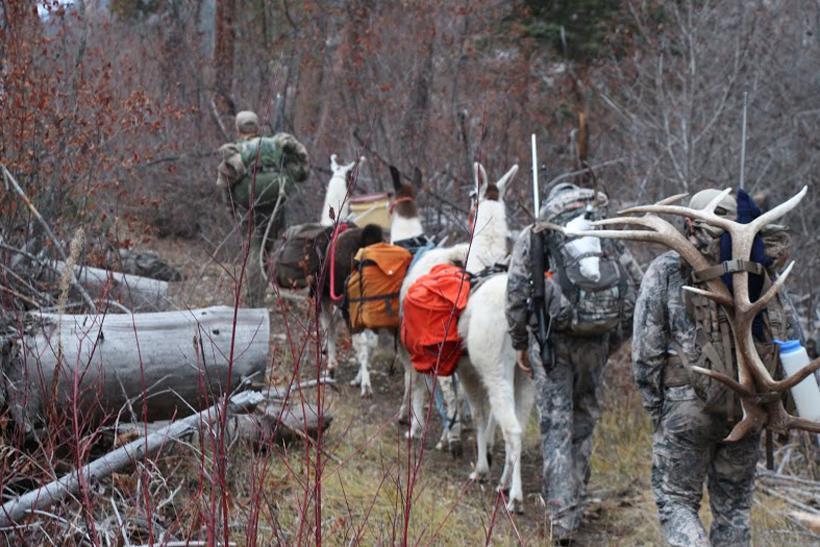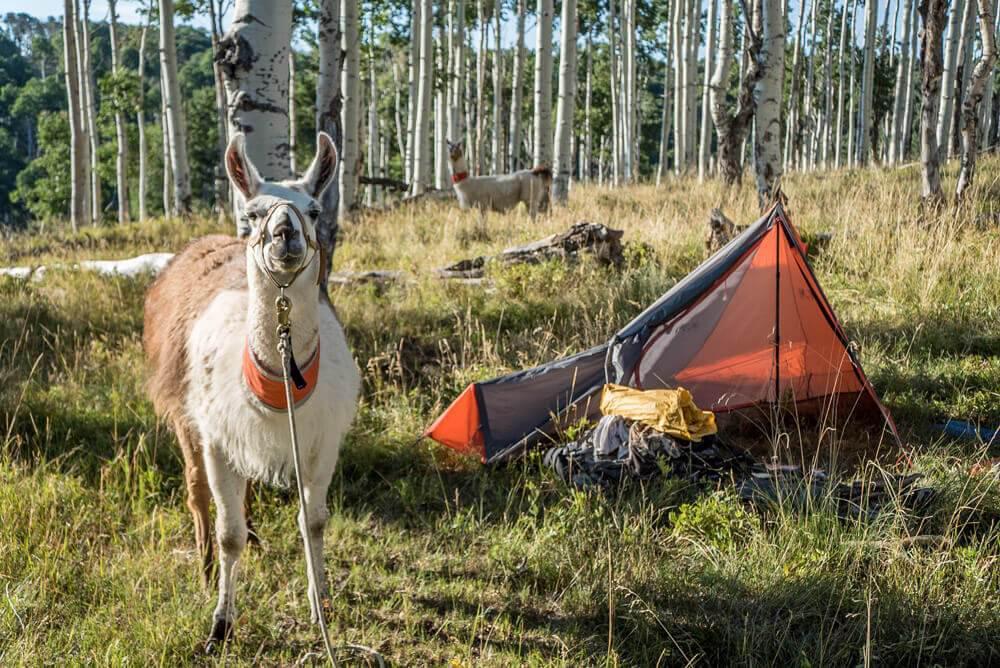The first image is the image on the left, the second image is the image on the right. Evaluate the accuracy of this statement regarding the images: "There are two alpaca in one image and multiple alpacas in the other image.". Is it true? Answer yes or no. Yes. The first image is the image on the left, the second image is the image on the right. Examine the images to the left and right. Is the description "One man in camo with a bow is leading no more than two packed llamas leftward in one image." accurate? Answer yes or no. No. 